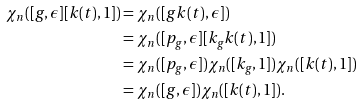Convert formula to latex. <formula><loc_0><loc_0><loc_500><loc_500>\chi _ { n } ( [ g , \epsilon ] [ k ( t ) , 1 ] ) & = \chi _ { n } ( [ g k ( t ) , \epsilon ] ) \\ & = \chi _ { n } ( [ p _ { g } , \epsilon ] [ k _ { g } k ( t ) , 1 ] ) \\ & = \chi _ { n } ( [ p _ { g } , \epsilon ] ) \chi _ { n } ( [ k _ { g } , 1 ] ) \chi _ { n } ( [ k ( t ) , 1 ] ) \\ & = \chi _ { n } ( [ g , \epsilon ] ) \chi _ { n } ( [ k ( t ) , 1 ] ) .</formula> 